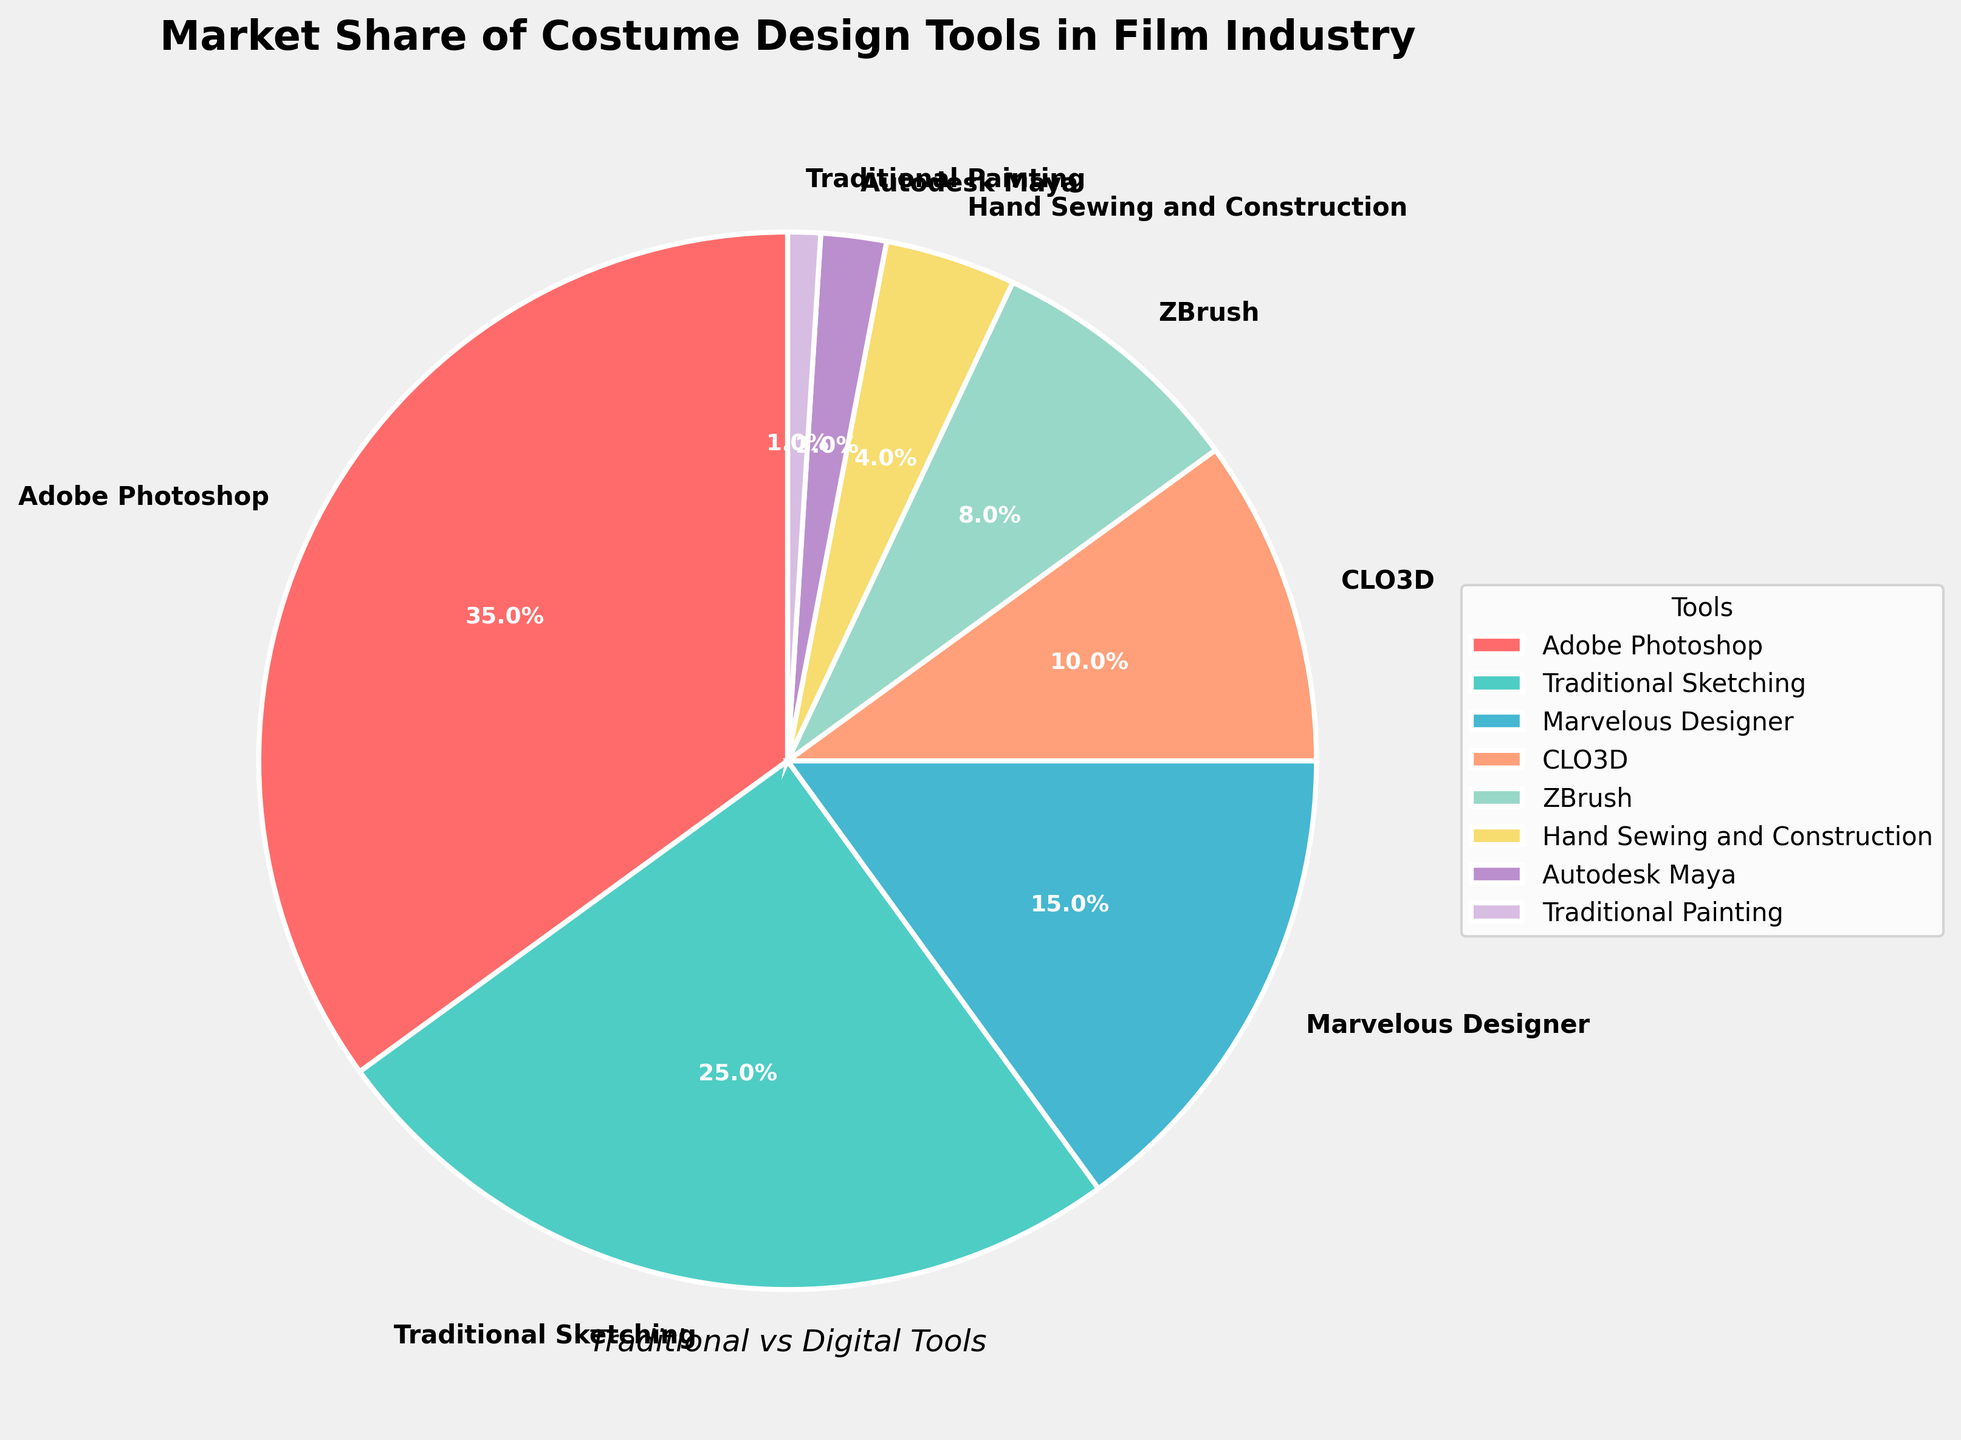What percentage of the market share do traditional tools account for? Traditional tools are Traditional Sketching, Hand Sewing and Construction, and Traditional Painting. Their market shares are 25%, 4%, and 1% respectively. Summing them up: 25 + 4 + 1 = 30%.
Answer: 30% Which tool has the largest market share? By looking at the slices of the pie chart, Adobe Photoshop has the largest slice, corresponding to the largest percentage.
Answer: Adobe Photoshop How does the market share of Adobe Photoshop compare to the combined market share of Marvelous Designer and CLO3D? Adobe Photoshop has a market share of 35%. Marvelous Designer and CLO3D have 15% and 10% respectively. Combined, Marvelous Designer and CLO3D have: 15 + 10 = 25%. Since 35% > 25%, Adobe Photoshop has a larger market share.
Answer: Adobe Photoshop has a larger market share What is the difference in market share between Traditional Sketching and Marvelous Designer? Traditional Sketching has a market share of 25%, and Marvelous Designer has 15%. The difference is: 25 - 15 = 10%.
Answer: 10% Which tool has the smallest market share? Looking at the smallest slices in the pie chart, Traditional Painting has the smallest market share of 1%.
Answer: Traditional Painting Which digital tool has the second largest market share? Among digital tools, Adobe Photoshop (35%), Marvelous Designer (15%), CLO3D (10%), ZBrush (8%), and Autodesk Maya (2%) are listed. The second largest is Marvelous Designer with 15%.
Answer: Marvelous Designer How much more market share does Adobe Photoshop have compared to all traditional tools combined? Adobe Photoshop has a market share of 35%. Traditional tools combined (Traditional Sketching 25%, Hand Sewing and Construction 4%, Traditional Painting 1%) total 30%. The difference is: 35 - 30 = 5%.
Answer: 5% Is the market share of digital tools (not including Adobe Photoshop) more than the market share of Traditional Sketching? Market shares for digital tools not including Adobe Photoshop: Marvelous Designer (15%), CLO3D (10%), ZBrush (8%), Autodesk Maya (2%) sum to: 15 + 10 + 8 + 2 = 35%. Traditional Sketching is 25%. Since 35% > 25%, the market share of the other digital tools is larger.
Answer: Yes What percentage of the market do CLO3D and ZBrush cover together? CLO3D has a market share of 10%, and ZBrush has 8%. Their combined percentage is: 10 + 8 = 18%.
Answer: 18% Compare the market share of Hand Sewing and Construction with that of Autodesk Maya. Hand Sewing and Construction has a market share of 4%, and Autodesk Maya has 2%. Since 4% > 2%, Hand Sewing and Construction has a larger market share.
Answer: Hand Sewing and Construction has a larger market share 